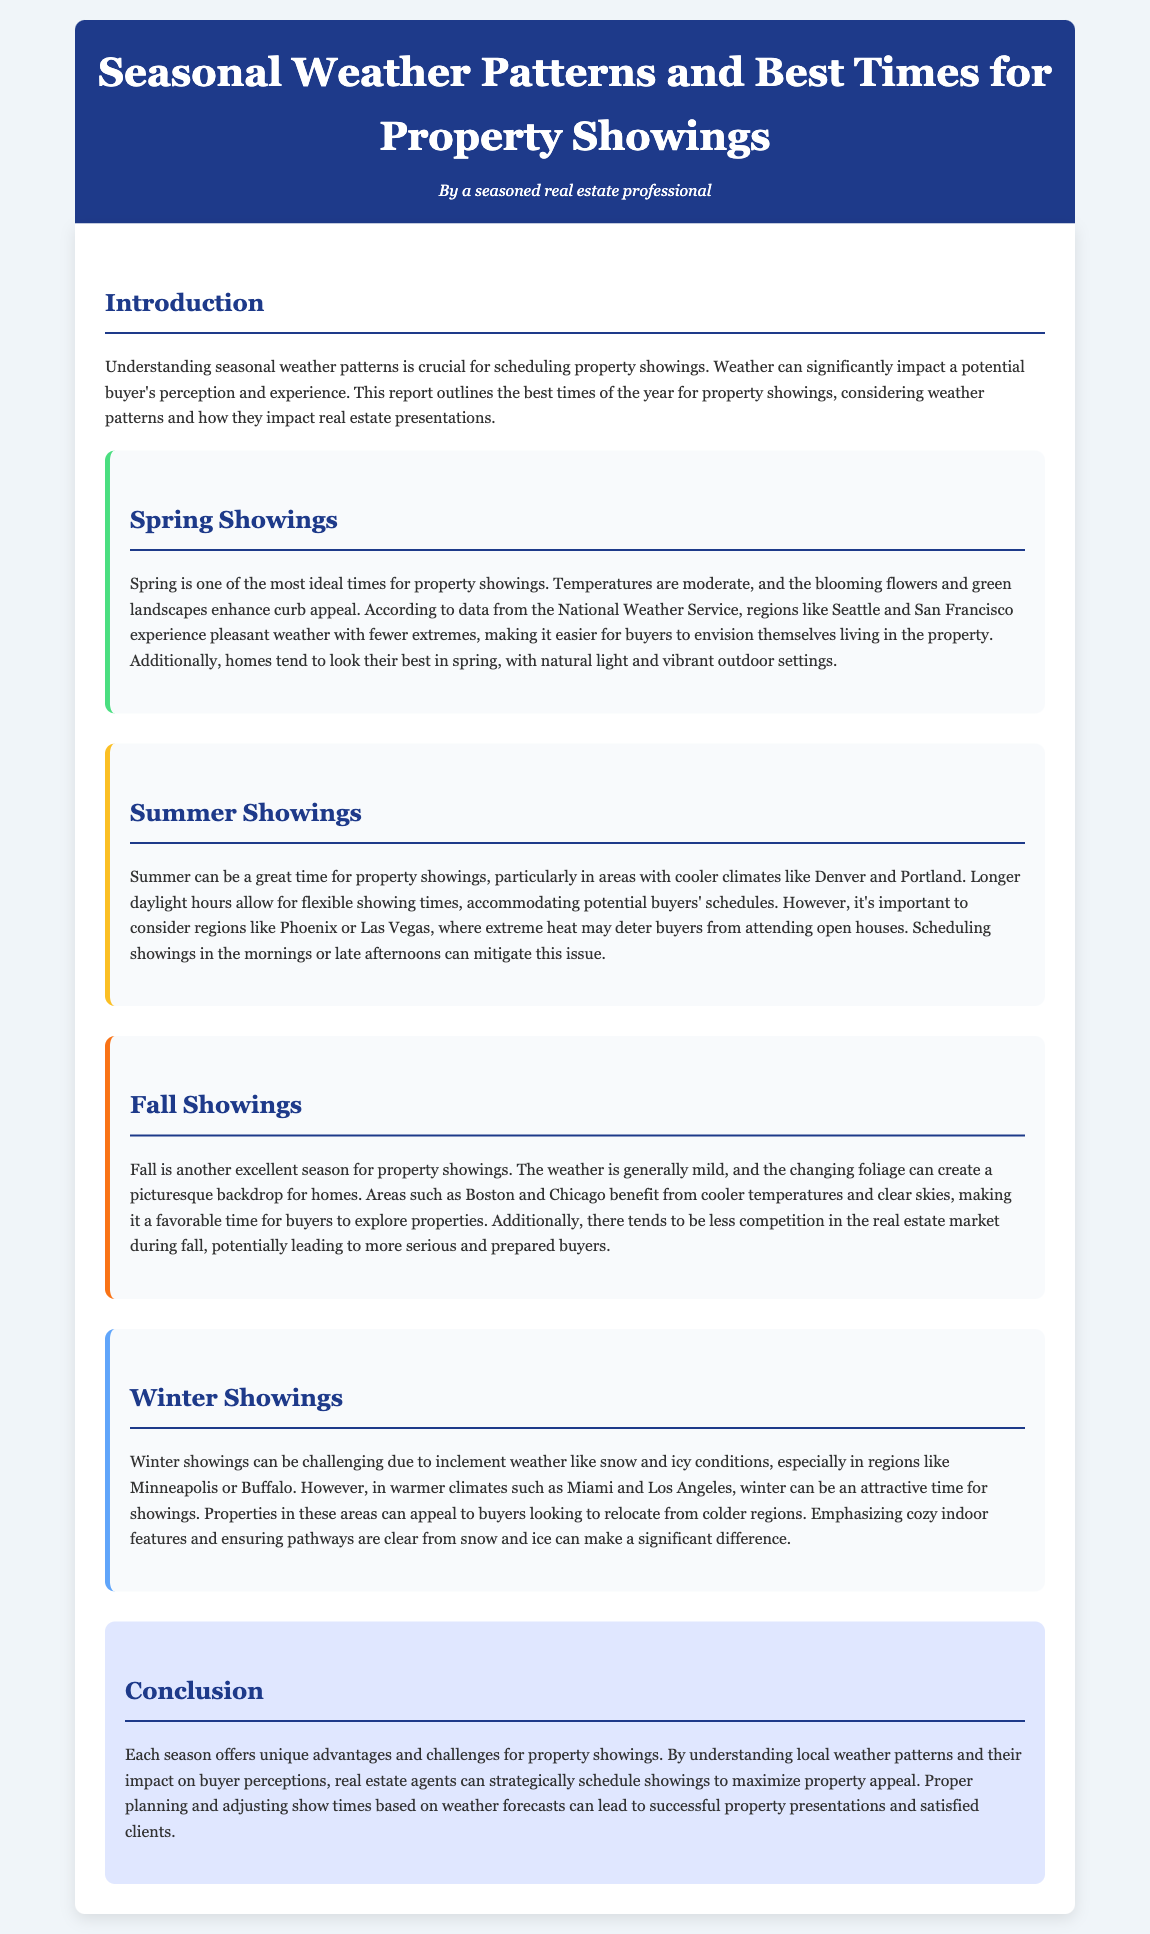What is the best season for property showings? The document states that spring is one of the most ideal times for property showings due to moderate temperatures and enhanced curb appeal.
Answer: Spring Which cities benefit from pleasant spring weather? According to the document, Seattle and San Francisco experience pleasant weather in spring, making it easier for buyers to envision themselves living in the property.
Answer: Seattle and San Francisco What should be considered when scheduling summer showings in hot climates? The document advises scheduling showings in the mornings or late afternoons in warm regions like Phoenix or Las Vegas to mitigate the impact of extreme heat.
Answer: Mornings or late afternoons What season tends to have less competition in the real estate market? Fall is noted in the document as a season with less competition, potentially leading to more serious buyers.
Answer: Fall How can winter showings be improved in warmer climates? The document suggests that properties in warmer climates like Miami and Los Angeles can appeal to buyers looking to relocate, thereby improving winter showings.
Answer: Emphasizing cozy indoor features In which regions can winter showings be particularly challenging? The document highlights that regions like Minneapolis or Buffalo experience challenges in winter showings due to inclement weather like snow and ice.
Answer: Minneapolis or Buffalo What is a significant visual enhancement for homes in spring? The document mentions that homes look their best in spring due to natural light and vibrant outdoor settings, which enhance curb appeal.
Answer: Natural light and vibrant outdoor settings What is the effect of weather on potential buyers' experiences according to the document? The document states that weather can significantly impact a potential buyer's perception and experience during property showings.
Answer: Perception and experience What is emphasized in winter showings in colder regions? The document points out that ensuring pathways are clear from snow and ice is crucial during winter showings in colder regions.
Answer: Clear pathways 